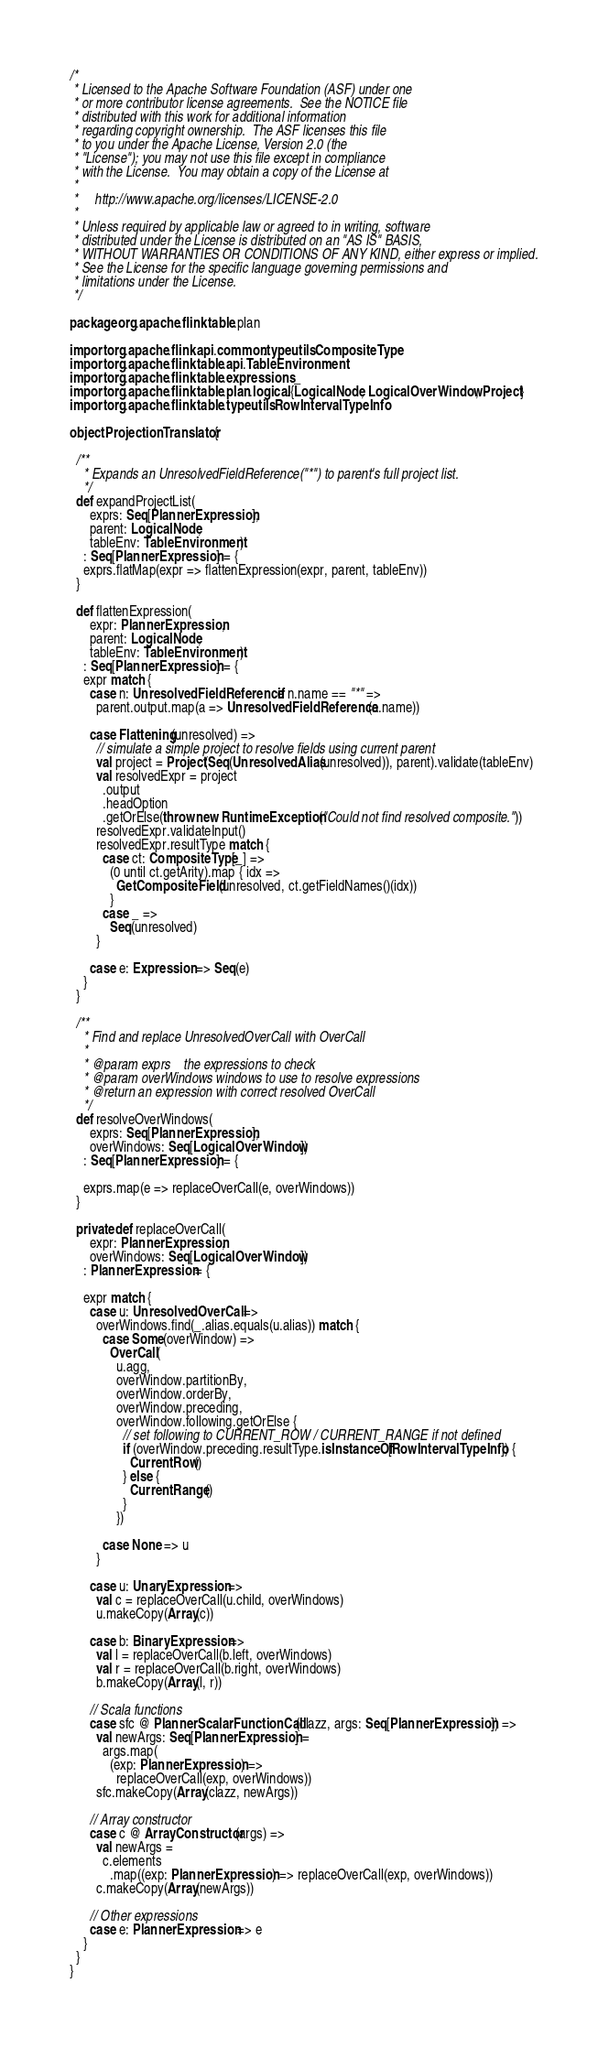<code> <loc_0><loc_0><loc_500><loc_500><_Scala_>/*
 * Licensed to the Apache Software Foundation (ASF) under one
 * or more contributor license agreements.  See the NOTICE file
 * distributed with this work for additional information
 * regarding copyright ownership.  The ASF licenses this file
 * to you under the Apache License, Version 2.0 (the
 * "License"); you may not use this file except in compliance
 * with the License.  You may obtain a copy of the License at
 *
 *     http://www.apache.org/licenses/LICENSE-2.0
 *
 * Unless required by applicable law or agreed to in writing, software
 * distributed under the License is distributed on an "AS IS" BASIS,
 * WITHOUT WARRANTIES OR CONDITIONS OF ANY KIND, either express or implied.
 * See the License for the specific language governing permissions and
 * limitations under the License.
 */

package org.apache.flink.table.plan

import org.apache.flink.api.common.typeutils.CompositeType
import org.apache.flink.table.api.TableEnvironment
import org.apache.flink.table.expressions._
import org.apache.flink.table.plan.logical.{LogicalNode, LogicalOverWindow, Project}
import org.apache.flink.table.typeutils.RowIntervalTypeInfo

object ProjectionTranslator {

  /**
    * Expands an UnresolvedFieldReference("*") to parent's full project list.
    */
  def expandProjectList(
      exprs: Seq[PlannerExpression],
      parent: LogicalNode,
      tableEnv: TableEnvironment)
    : Seq[PlannerExpression] = {
    exprs.flatMap(expr => flattenExpression(expr, parent, tableEnv))
  }

  def flattenExpression(
      expr: PlannerExpression,
      parent: LogicalNode,
      tableEnv: TableEnvironment)
    : Seq[PlannerExpression] = {
    expr match {
      case n: UnresolvedFieldReference if n.name == "*" =>
        parent.output.map(a => UnresolvedFieldReference(a.name))

      case Flattening(unresolved) =>
        // simulate a simple project to resolve fields using current parent
        val project = Project(Seq(UnresolvedAlias(unresolved)), parent).validate(tableEnv)
        val resolvedExpr = project
          .output
          .headOption
          .getOrElse(throw new RuntimeException("Could not find resolved composite."))
        resolvedExpr.validateInput()
        resolvedExpr.resultType match {
          case ct: CompositeType[_] =>
            (0 until ct.getArity).map { idx =>
              GetCompositeField(unresolved, ct.getFieldNames()(idx))
            }
          case _ =>
            Seq(unresolved)
        }

      case e: Expression => Seq(e)
    }
  }

  /**
    * Find and replace UnresolvedOverCall with OverCall
    *
    * @param exprs    the expressions to check
    * @param overWindows windows to use to resolve expressions
    * @return an expression with correct resolved OverCall
    */
  def resolveOverWindows(
      exprs: Seq[PlannerExpression],
      overWindows: Seq[LogicalOverWindow])
    : Seq[PlannerExpression] = {

    exprs.map(e => replaceOverCall(e, overWindows))
  }

  private def replaceOverCall(
      expr: PlannerExpression,
      overWindows: Seq[LogicalOverWindow])
    : PlannerExpression = {

    expr match {
      case u: UnresolvedOverCall =>
        overWindows.find(_.alias.equals(u.alias)) match {
          case Some(overWindow) =>
            OverCall(
              u.agg,
              overWindow.partitionBy,
              overWindow.orderBy,
              overWindow.preceding,
              overWindow.following.getOrElse {
                // set following to CURRENT_ROW / CURRENT_RANGE if not defined
                if (overWindow.preceding.resultType.isInstanceOf[RowIntervalTypeInfo]) {
                  CurrentRow()
                } else {
                  CurrentRange()
                }
              })

          case None => u
        }

      case u: UnaryExpression =>
        val c = replaceOverCall(u.child, overWindows)
        u.makeCopy(Array(c))

      case b: BinaryExpression =>
        val l = replaceOverCall(b.left, overWindows)
        val r = replaceOverCall(b.right, overWindows)
        b.makeCopy(Array(l, r))

      // Scala functions
      case sfc @ PlannerScalarFunctionCall(clazz, args: Seq[PlannerExpression]) =>
        val newArgs: Seq[PlannerExpression] =
          args.map(
            (exp: PlannerExpression) =>
              replaceOverCall(exp, overWindows))
        sfc.makeCopy(Array(clazz, newArgs))

      // Array constructor
      case c @ ArrayConstructor(args) =>
        val newArgs =
          c.elements
            .map((exp: PlannerExpression) => replaceOverCall(exp, overWindows))
        c.makeCopy(Array(newArgs))

      // Other expressions
      case e: PlannerExpression => e
    }
  }
}
</code> 